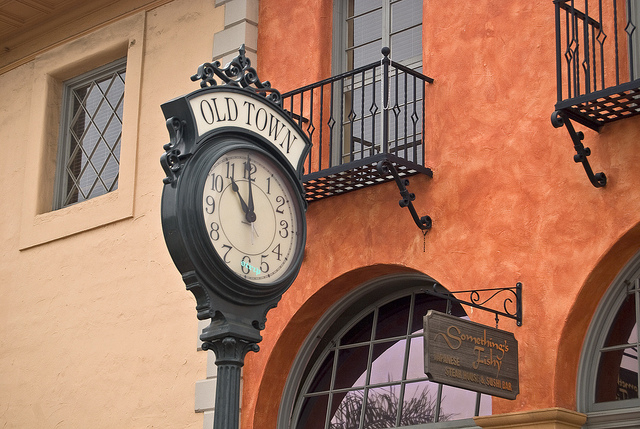<image>What fast food place is behind the clock? I am not certain. There may be a "something's fishy" place or a cafe, but there could also be nothing. What fast food place is behind the clock? I don't know what fast food place is behind the clock. It could be something fishy, a bar, a cafe, or something sushi. 